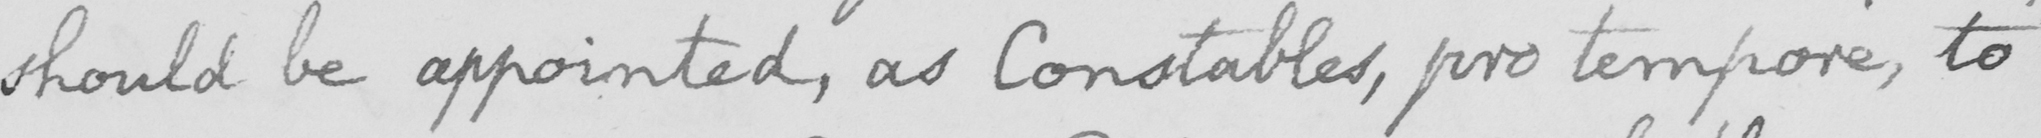What text is written in this handwritten line? should be appointed , as Constables , pro tempore , to 